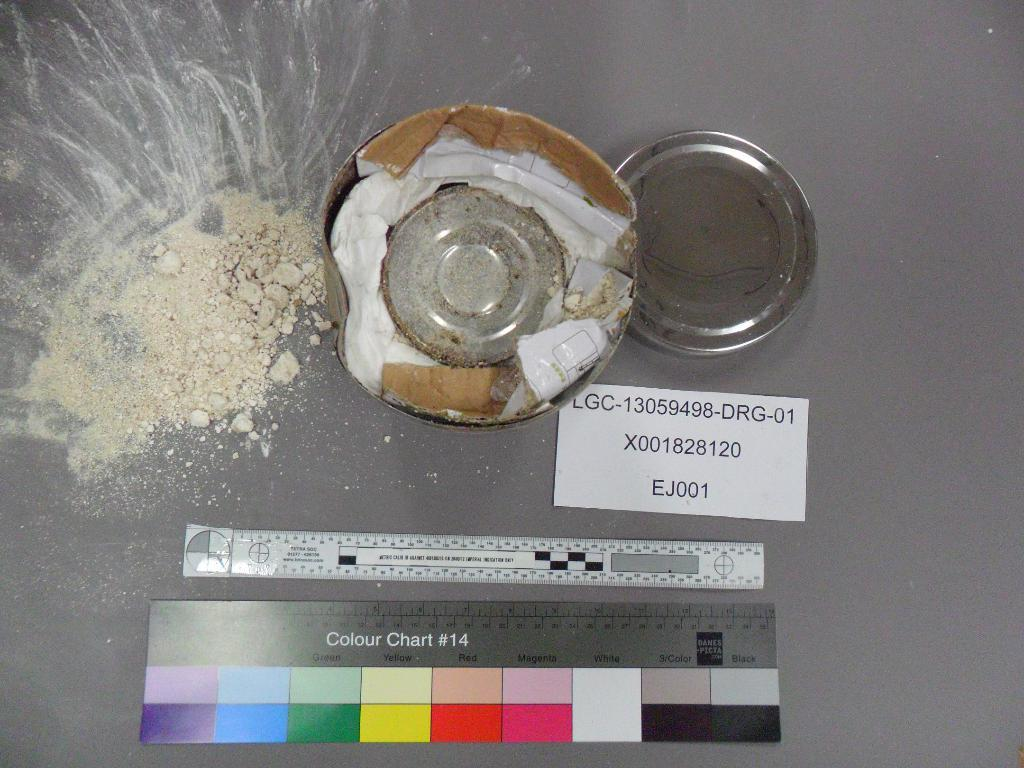What is the focus of the image? The image is zoomed in. What can be seen in the center of the image? There are plates in the center of the image. What substance is visible in the image? There is some powder visible in the image. What is the purpose of the papers in the image? The papers are placed on top of an object in the image. What type of instrument is being played in the image? There is no instrument present in the image. What company is responsible for the lunchroom in the image? There is no lunchroom present in the image. 